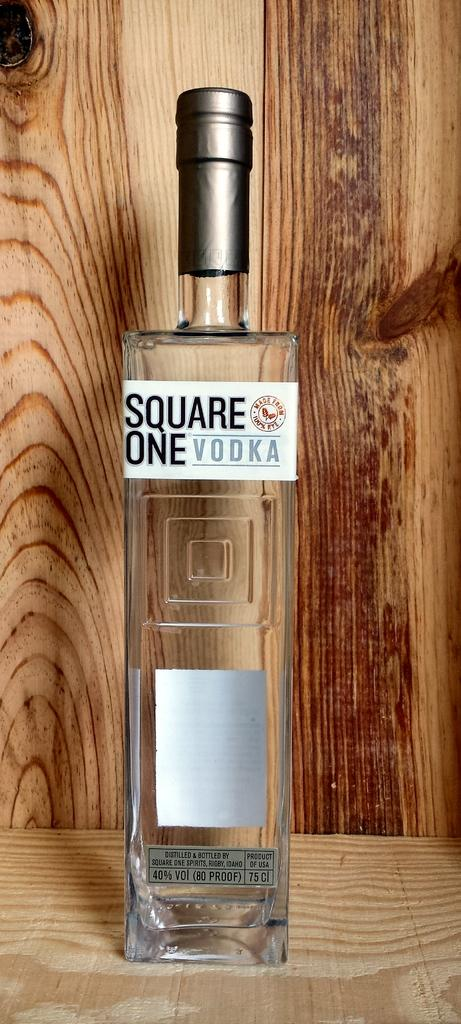What is the main object in the image? There is a vodka bottle in the image. Where is the vodka bottle located? The vodka bottle is placed on a surface. What can be seen in the background of the image? There is a wooden wall in the background of the image. What type of health record is visible on the wooden wall in the image? There is no health record visible on the wooden wall in the image; it only features a wooden wall in the background. 